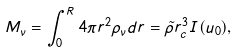Convert formula to latex. <formula><loc_0><loc_0><loc_500><loc_500>M _ { \nu } = \int ^ { R } _ { 0 } 4 \pi r ^ { 2 } \rho _ { \nu } d r = \tilde { \rho } r _ { c } ^ { 3 } I ( u _ { 0 } ) ,</formula> 